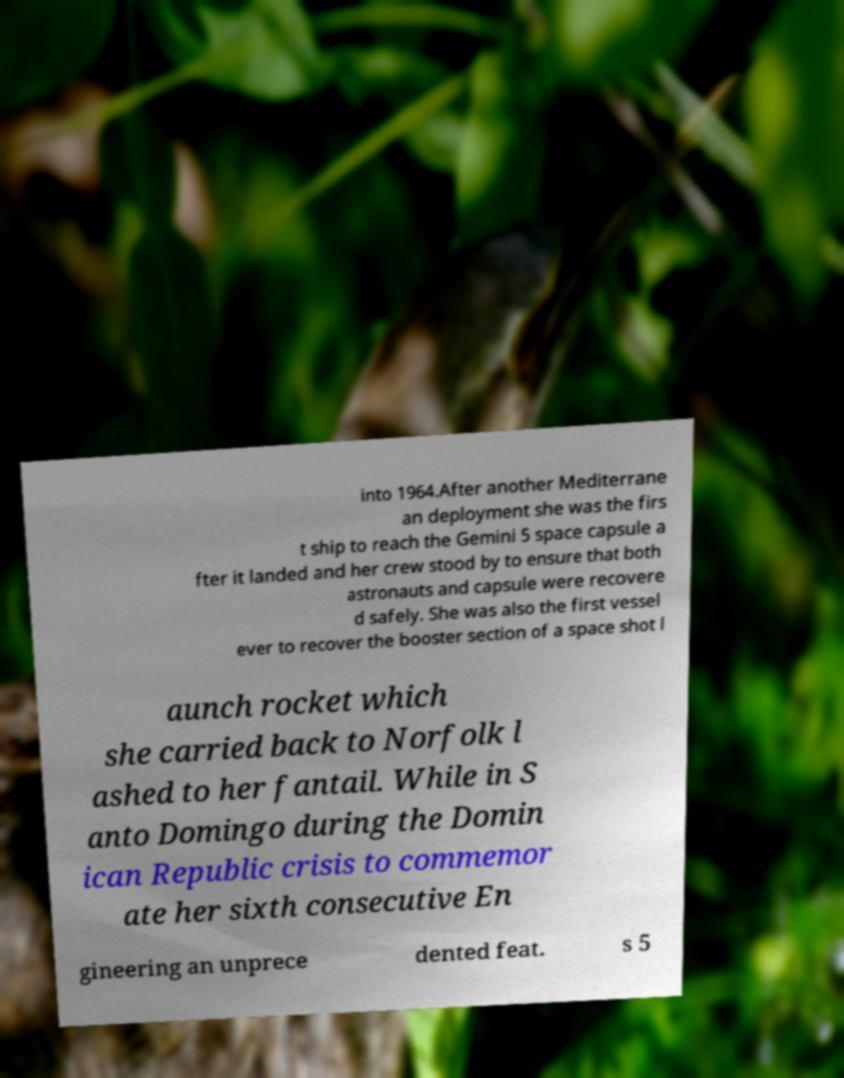What messages or text are displayed in this image? I need them in a readable, typed format. into 1964.After another Mediterrane an deployment she was the firs t ship to reach the Gemini 5 space capsule a fter it landed and her crew stood by to ensure that both astronauts and capsule were recovere d safely. She was also the first vessel ever to recover the booster section of a space shot l aunch rocket which she carried back to Norfolk l ashed to her fantail. While in S anto Domingo during the Domin ican Republic crisis to commemor ate her sixth consecutive En gineering an unprece dented feat. s 5 